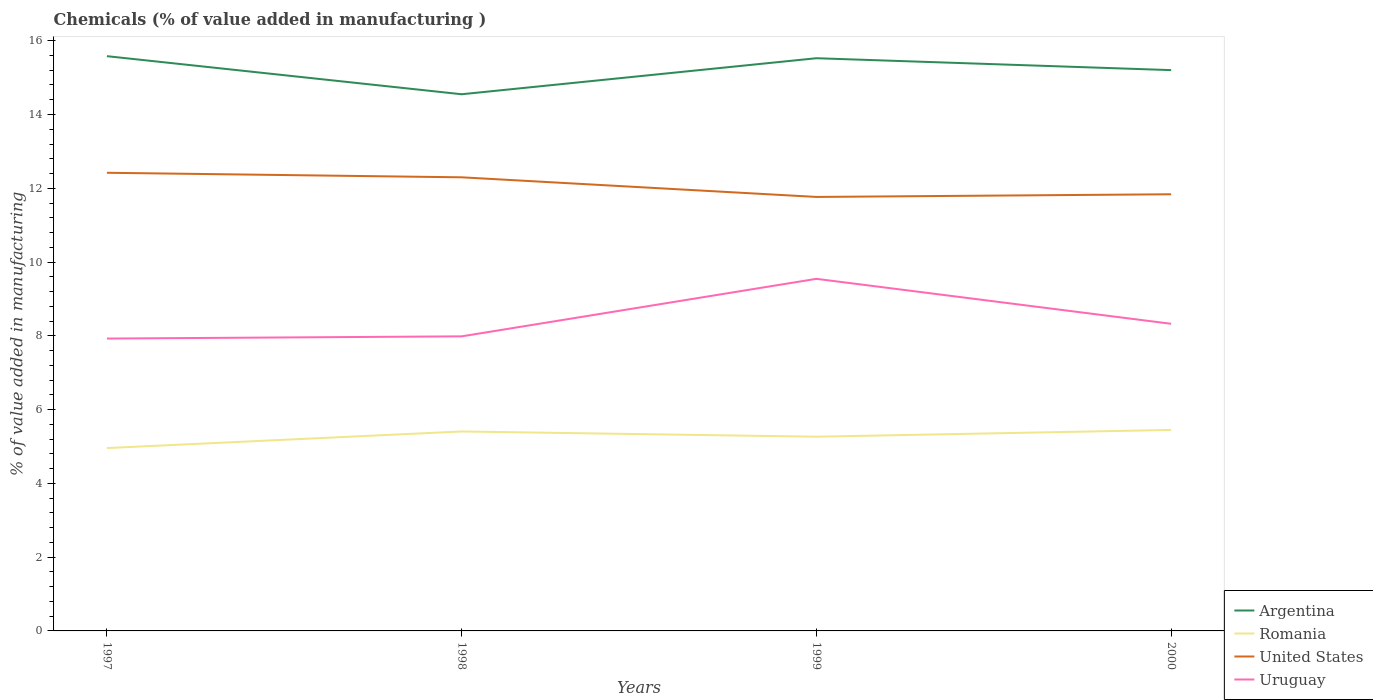Is the number of lines equal to the number of legend labels?
Your response must be concise. Yes. Across all years, what is the maximum value added in manufacturing chemicals in Argentina?
Your answer should be very brief. 14.55. What is the total value added in manufacturing chemicals in Argentina in the graph?
Offer a terse response. -0.98. What is the difference between the highest and the second highest value added in manufacturing chemicals in Uruguay?
Keep it short and to the point. 1.62. What is the difference between the highest and the lowest value added in manufacturing chemicals in United States?
Your answer should be very brief. 2. Does the graph contain grids?
Your response must be concise. No. How many legend labels are there?
Provide a succinct answer. 4. What is the title of the graph?
Give a very brief answer. Chemicals (% of value added in manufacturing ). What is the label or title of the X-axis?
Provide a short and direct response. Years. What is the label or title of the Y-axis?
Offer a terse response. % of value added in manufacturing. What is the % of value added in manufacturing in Argentina in 1997?
Make the answer very short. 15.58. What is the % of value added in manufacturing of Romania in 1997?
Keep it short and to the point. 4.96. What is the % of value added in manufacturing of United States in 1997?
Offer a terse response. 12.42. What is the % of value added in manufacturing in Uruguay in 1997?
Provide a succinct answer. 7.93. What is the % of value added in manufacturing in Argentina in 1998?
Your answer should be very brief. 14.55. What is the % of value added in manufacturing in Romania in 1998?
Give a very brief answer. 5.41. What is the % of value added in manufacturing of United States in 1998?
Provide a short and direct response. 12.3. What is the % of value added in manufacturing in Uruguay in 1998?
Offer a very short reply. 7.99. What is the % of value added in manufacturing of Argentina in 1999?
Your answer should be very brief. 15.53. What is the % of value added in manufacturing of Romania in 1999?
Your response must be concise. 5.27. What is the % of value added in manufacturing of United States in 1999?
Ensure brevity in your answer.  11.76. What is the % of value added in manufacturing in Uruguay in 1999?
Provide a short and direct response. 9.54. What is the % of value added in manufacturing in Argentina in 2000?
Your response must be concise. 15.2. What is the % of value added in manufacturing of Romania in 2000?
Give a very brief answer. 5.45. What is the % of value added in manufacturing of United States in 2000?
Make the answer very short. 11.84. What is the % of value added in manufacturing in Uruguay in 2000?
Your answer should be compact. 8.33. Across all years, what is the maximum % of value added in manufacturing in Argentina?
Provide a succinct answer. 15.58. Across all years, what is the maximum % of value added in manufacturing in Romania?
Provide a short and direct response. 5.45. Across all years, what is the maximum % of value added in manufacturing of United States?
Ensure brevity in your answer.  12.42. Across all years, what is the maximum % of value added in manufacturing of Uruguay?
Provide a short and direct response. 9.54. Across all years, what is the minimum % of value added in manufacturing of Argentina?
Provide a short and direct response. 14.55. Across all years, what is the minimum % of value added in manufacturing in Romania?
Offer a very short reply. 4.96. Across all years, what is the minimum % of value added in manufacturing of United States?
Your answer should be very brief. 11.76. Across all years, what is the minimum % of value added in manufacturing of Uruguay?
Give a very brief answer. 7.93. What is the total % of value added in manufacturing in Argentina in the graph?
Offer a very short reply. 60.86. What is the total % of value added in manufacturing of Romania in the graph?
Make the answer very short. 21.08. What is the total % of value added in manufacturing in United States in the graph?
Your answer should be very brief. 48.32. What is the total % of value added in manufacturing of Uruguay in the graph?
Keep it short and to the point. 33.78. What is the difference between the % of value added in manufacturing of Argentina in 1997 and that in 1998?
Give a very brief answer. 1.03. What is the difference between the % of value added in manufacturing of Romania in 1997 and that in 1998?
Give a very brief answer. -0.45. What is the difference between the % of value added in manufacturing of United States in 1997 and that in 1998?
Give a very brief answer. 0.12. What is the difference between the % of value added in manufacturing of Uruguay in 1997 and that in 1998?
Keep it short and to the point. -0.06. What is the difference between the % of value added in manufacturing of Argentina in 1997 and that in 1999?
Your answer should be compact. 0.06. What is the difference between the % of value added in manufacturing of Romania in 1997 and that in 1999?
Offer a very short reply. -0.31. What is the difference between the % of value added in manufacturing of United States in 1997 and that in 1999?
Make the answer very short. 0.66. What is the difference between the % of value added in manufacturing in Uruguay in 1997 and that in 1999?
Your response must be concise. -1.62. What is the difference between the % of value added in manufacturing in Argentina in 1997 and that in 2000?
Your answer should be compact. 0.38. What is the difference between the % of value added in manufacturing of Romania in 1997 and that in 2000?
Give a very brief answer. -0.49. What is the difference between the % of value added in manufacturing in United States in 1997 and that in 2000?
Your response must be concise. 0.58. What is the difference between the % of value added in manufacturing of Uruguay in 1997 and that in 2000?
Ensure brevity in your answer.  -0.4. What is the difference between the % of value added in manufacturing of Argentina in 1998 and that in 1999?
Offer a terse response. -0.98. What is the difference between the % of value added in manufacturing of Romania in 1998 and that in 1999?
Keep it short and to the point. 0.14. What is the difference between the % of value added in manufacturing in United States in 1998 and that in 1999?
Your answer should be very brief. 0.53. What is the difference between the % of value added in manufacturing in Uruguay in 1998 and that in 1999?
Provide a short and direct response. -1.56. What is the difference between the % of value added in manufacturing in Argentina in 1998 and that in 2000?
Give a very brief answer. -0.65. What is the difference between the % of value added in manufacturing in Romania in 1998 and that in 2000?
Keep it short and to the point. -0.04. What is the difference between the % of value added in manufacturing of United States in 1998 and that in 2000?
Ensure brevity in your answer.  0.46. What is the difference between the % of value added in manufacturing in Uruguay in 1998 and that in 2000?
Make the answer very short. -0.34. What is the difference between the % of value added in manufacturing of Argentina in 1999 and that in 2000?
Make the answer very short. 0.32. What is the difference between the % of value added in manufacturing in Romania in 1999 and that in 2000?
Ensure brevity in your answer.  -0.18. What is the difference between the % of value added in manufacturing of United States in 1999 and that in 2000?
Ensure brevity in your answer.  -0.07. What is the difference between the % of value added in manufacturing of Uruguay in 1999 and that in 2000?
Your answer should be compact. 1.22. What is the difference between the % of value added in manufacturing in Argentina in 1997 and the % of value added in manufacturing in Romania in 1998?
Your response must be concise. 10.17. What is the difference between the % of value added in manufacturing in Argentina in 1997 and the % of value added in manufacturing in United States in 1998?
Provide a short and direct response. 3.28. What is the difference between the % of value added in manufacturing in Argentina in 1997 and the % of value added in manufacturing in Uruguay in 1998?
Keep it short and to the point. 7.6. What is the difference between the % of value added in manufacturing in Romania in 1997 and the % of value added in manufacturing in United States in 1998?
Your answer should be compact. -7.34. What is the difference between the % of value added in manufacturing in Romania in 1997 and the % of value added in manufacturing in Uruguay in 1998?
Provide a short and direct response. -3.03. What is the difference between the % of value added in manufacturing in United States in 1997 and the % of value added in manufacturing in Uruguay in 1998?
Keep it short and to the point. 4.43. What is the difference between the % of value added in manufacturing in Argentina in 1997 and the % of value added in manufacturing in Romania in 1999?
Make the answer very short. 10.32. What is the difference between the % of value added in manufacturing in Argentina in 1997 and the % of value added in manufacturing in United States in 1999?
Give a very brief answer. 3.82. What is the difference between the % of value added in manufacturing in Argentina in 1997 and the % of value added in manufacturing in Uruguay in 1999?
Provide a succinct answer. 6.04. What is the difference between the % of value added in manufacturing of Romania in 1997 and the % of value added in manufacturing of United States in 1999?
Your answer should be very brief. -6.81. What is the difference between the % of value added in manufacturing in Romania in 1997 and the % of value added in manufacturing in Uruguay in 1999?
Give a very brief answer. -4.59. What is the difference between the % of value added in manufacturing of United States in 1997 and the % of value added in manufacturing of Uruguay in 1999?
Keep it short and to the point. 2.88. What is the difference between the % of value added in manufacturing in Argentina in 1997 and the % of value added in manufacturing in Romania in 2000?
Provide a succinct answer. 10.13. What is the difference between the % of value added in manufacturing of Argentina in 1997 and the % of value added in manufacturing of United States in 2000?
Offer a very short reply. 3.74. What is the difference between the % of value added in manufacturing of Argentina in 1997 and the % of value added in manufacturing of Uruguay in 2000?
Provide a short and direct response. 7.25. What is the difference between the % of value added in manufacturing in Romania in 1997 and the % of value added in manufacturing in United States in 2000?
Ensure brevity in your answer.  -6.88. What is the difference between the % of value added in manufacturing of Romania in 1997 and the % of value added in manufacturing of Uruguay in 2000?
Give a very brief answer. -3.37. What is the difference between the % of value added in manufacturing of United States in 1997 and the % of value added in manufacturing of Uruguay in 2000?
Ensure brevity in your answer.  4.09. What is the difference between the % of value added in manufacturing of Argentina in 1998 and the % of value added in manufacturing of Romania in 1999?
Your response must be concise. 9.28. What is the difference between the % of value added in manufacturing of Argentina in 1998 and the % of value added in manufacturing of United States in 1999?
Provide a succinct answer. 2.78. What is the difference between the % of value added in manufacturing in Argentina in 1998 and the % of value added in manufacturing in Uruguay in 1999?
Your answer should be compact. 5. What is the difference between the % of value added in manufacturing in Romania in 1998 and the % of value added in manufacturing in United States in 1999?
Your answer should be very brief. -6.36. What is the difference between the % of value added in manufacturing in Romania in 1998 and the % of value added in manufacturing in Uruguay in 1999?
Provide a short and direct response. -4.14. What is the difference between the % of value added in manufacturing in United States in 1998 and the % of value added in manufacturing in Uruguay in 1999?
Give a very brief answer. 2.75. What is the difference between the % of value added in manufacturing of Argentina in 1998 and the % of value added in manufacturing of Romania in 2000?
Provide a short and direct response. 9.1. What is the difference between the % of value added in manufacturing in Argentina in 1998 and the % of value added in manufacturing in United States in 2000?
Keep it short and to the point. 2.71. What is the difference between the % of value added in manufacturing of Argentina in 1998 and the % of value added in manufacturing of Uruguay in 2000?
Your response must be concise. 6.22. What is the difference between the % of value added in manufacturing in Romania in 1998 and the % of value added in manufacturing in United States in 2000?
Offer a terse response. -6.43. What is the difference between the % of value added in manufacturing of Romania in 1998 and the % of value added in manufacturing of Uruguay in 2000?
Your answer should be compact. -2.92. What is the difference between the % of value added in manufacturing in United States in 1998 and the % of value added in manufacturing in Uruguay in 2000?
Make the answer very short. 3.97. What is the difference between the % of value added in manufacturing of Argentina in 1999 and the % of value added in manufacturing of Romania in 2000?
Your answer should be very brief. 10.08. What is the difference between the % of value added in manufacturing in Argentina in 1999 and the % of value added in manufacturing in United States in 2000?
Your answer should be compact. 3.69. What is the difference between the % of value added in manufacturing of Argentina in 1999 and the % of value added in manufacturing of Uruguay in 2000?
Give a very brief answer. 7.2. What is the difference between the % of value added in manufacturing of Romania in 1999 and the % of value added in manufacturing of United States in 2000?
Ensure brevity in your answer.  -6.57. What is the difference between the % of value added in manufacturing in Romania in 1999 and the % of value added in manufacturing in Uruguay in 2000?
Your answer should be compact. -3.06. What is the difference between the % of value added in manufacturing of United States in 1999 and the % of value added in manufacturing of Uruguay in 2000?
Provide a short and direct response. 3.44. What is the average % of value added in manufacturing of Argentina per year?
Your response must be concise. 15.21. What is the average % of value added in manufacturing of Romania per year?
Your answer should be very brief. 5.27. What is the average % of value added in manufacturing in United States per year?
Your answer should be compact. 12.08. What is the average % of value added in manufacturing of Uruguay per year?
Your answer should be very brief. 8.45. In the year 1997, what is the difference between the % of value added in manufacturing in Argentina and % of value added in manufacturing in Romania?
Make the answer very short. 10.62. In the year 1997, what is the difference between the % of value added in manufacturing of Argentina and % of value added in manufacturing of United States?
Offer a very short reply. 3.16. In the year 1997, what is the difference between the % of value added in manufacturing in Argentina and % of value added in manufacturing in Uruguay?
Provide a succinct answer. 7.66. In the year 1997, what is the difference between the % of value added in manufacturing in Romania and % of value added in manufacturing in United States?
Your response must be concise. -7.46. In the year 1997, what is the difference between the % of value added in manufacturing of Romania and % of value added in manufacturing of Uruguay?
Offer a terse response. -2.97. In the year 1997, what is the difference between the % of value added in manufacturing in United States and % of value added in manufacturing in Uruguay?
Your response must be concise. 4.49. In the year 1998, what is the difference between the % of value added in manufacturing in Argentina and % of value added in manufacturing in Romania?
Ensure brevity in your answer.  9.14. In the year 1998, what is the difference between the % of value added in manufacturing in Argentina and % of value added in manufacturing in United States?
Your response must be concise. 2.25. In the year 1998, what is the difference between the % of value added in manufacturing of Argentina and % of value added in manufacturing of Uruguay?
Your response must be concise. 6.56. In the year 1998, what is the difference between the % of value added in manufacturing in Romania and % of value added in manufacturing in United States?
Offer a very short reply. -6.89. In the year 1998, what is the difference between the % of value added in manufacturing in Romania and % of value added in manufacturing in Uruguay?
Provide a succinct answer. -2.58. In the year 1998, what is the difference between the % of value added in manufacturing in United States and % of value added in manufacturing in Uruguay?
Offer a very short reply. 4.31. In the year 1999, what is the difference between the % of value added in manufacturing of Argentina and % of value added in manufacturing of Romania?
Offer a terse response. 10.26. In the year 1999, what is the difference between the % of value added in manufacturing in Argentina and % of value added in manufacturing in United States?
Make the answer very short. 3.76. In the year 1999, what is the difference between the % of value added in manufacturing in Argentina and % of value added in manufacturing in Uruguay?
Make the answer very short. 5.98. In the year 1999, what is the difference between the % of value added in manufacturing of Romania and % of value added in manufacturing of United States?
Offer a very short reply. -6.5. In the year 1999, what is the difference between the % of value added in manufacturing in Romania and % of value added in manufacturing in Uruguay?
Provide a short and direct response. -4.28. In the year 1999, what is the difference between the % of value added in manufacturing in United States and % of value added in manufacturing in Uruguay?
Your response must be concise. 2.22. In the year 2000, what is the difference between the % of value added in manufacturing of Argentina and % of value added in manufacturing of Romania?
Your response must be concise. 9.75. In the year 2000, what is the difference between the % of value added in manufacturing in Argentina and % of value added in manufacturing in United States?
Provide a short and direct response. 3.37. In the year 2000, what is the difference between the % of value added in manufacturing in Argentina and % of value added in manufacturing in Uruguay?
Keep it short and to the point. 6.88. In the year 2000, what is the difference between the % of value added in manufacturing in Romania and % of value added in manufacturing in United States?
Provide a short and direct response. -6.39. In the year 2000, what is the difference between the % of value added in manufacturing in Romania and % of value added in manufacturing in Uruguay?
Offer a very short reply. -2.88. In the year 2000, what is the difference between the % of value added in manufacturing in United States and % of value added in manufacturing in Uruguay?
Offer a terse response. 3.51. What is the ratio of the % of value added in manufacturing of Argentina in 1997 to that in 1998?
Your answer should be very brief. 1.07. What is the ratio of the % of value added in manufacturing of Romania in 1997 to that in 1998?
Keep it short and to the point. 0.92. What is the ratio of the % of value added in manufacturing of United States in 1997 to that in 1998?
Your answer should be very brief. 1.01. What is the ratio of the % of value added in manufacturing in Uruguay in 1997 to that in 1998?
Your response must be concise. 0.99. What is the ratio of the % of value added in manufacturing of Argentina in 1997 to that in 1999?
Provide a short and direct response. 1. What is the ratio of the % of value added in manufacturing of Romania in 1997 to that in 1999?
Offer a very short reply. 0.94. What is the ratio of the % of value added in manufacturing in United States in 1997 to that in 1999?
Offer a terse response. 1.06. What is the ratio of the % of value added in manufacturing in Uruguay in 1997 to that in 1999?
Your answer should be very brief. 0.83. What is the ratio of the % of value added in manufacturing of Argentina in 1997 to that in 2000?
Give a very brief answer. 1.02. What is the ratio of the % of value added in manufacturing in Romania in 1997 to that in 2000?
Ensure brevity in your answer.  0.91. What is the ratio of the % of value added in manufacturing in United States in 1997 to that in 2000?
Provide a short and direct response. 1.05. What is the ratio of the % of value added in manufacturing of Uruguay in 1997 to that in 2000?
Provide a succinct answer. 0.95. What is the ratio of the % of value added in manufacturing in Argentina in 1998 to that in 1999?
Give a very brief answer. 0.94. What is the ratio of the % of value added in manufacturing in Romania in 1998 to that in 1999?
Offer a very short reply. 1.03. What is the ratio of the % of value added in manufacturing in United States in 1998 to that in 1999?
Ensure brevity in your answer.  1.05. What is the ratio of the % of value added in manufacturing of Uruguay in 1998 to that in 1999?
Offer a very short reply. 0.84. What is the ratio of the % of value added in manufacturing in United States in 1998 to that in 2000?
Provide a succinct answer. 1.04. What is the ratio of the % of value added in manufacturing in Uruguay in 1998 to that in 2000?
Offer a terse response. 0.96. What is the ratio of the % of value added in manufacturing in Argentina in 1999 to that in 2000?
Your response must be concise. 1.02. What is the ratio of the % of value added in manufacturing in Romania in 1999 to that in 2000?
Make the answer very short. 0.97. What is the ratio of the % of value added in manufacturing of Uruguay in 1999 to that in 2000?
Make the answer very short. 1.15. What is the difference between the highest and the second highest % of value added in manufacturing of Argentina?
Your answer should be very brief. 0.06. What is the difference between the highest and the second highest % of value added in manufacturing of Romania?
Your answer should be very brief. 0.04. What is the difference between the highest and the second highest % of value added in manufacturing of United States?
Your answer should be very brief. 0.12. What is the difference between the highest and the second highest % of value added in manufacturing in Uruguay?
Provide a succinct answer. 1.22. What is the difference between the highest and the lowest % of value added in manufacturing in Argentina?
Make the answer very short. 1.03. What is the difference between the highest and the lowest % of value added in manufacturing in Romania?
Ensure brevity in your answer.  0.49. What is the difference between the highest and the lowest % of value added in manufacturing in United States?
Make the answer very short. 0.66. What is the difference between the highest and the lowest % of value added in manufacturing in Uruguay?
Offer a very short reply. 1.62. 